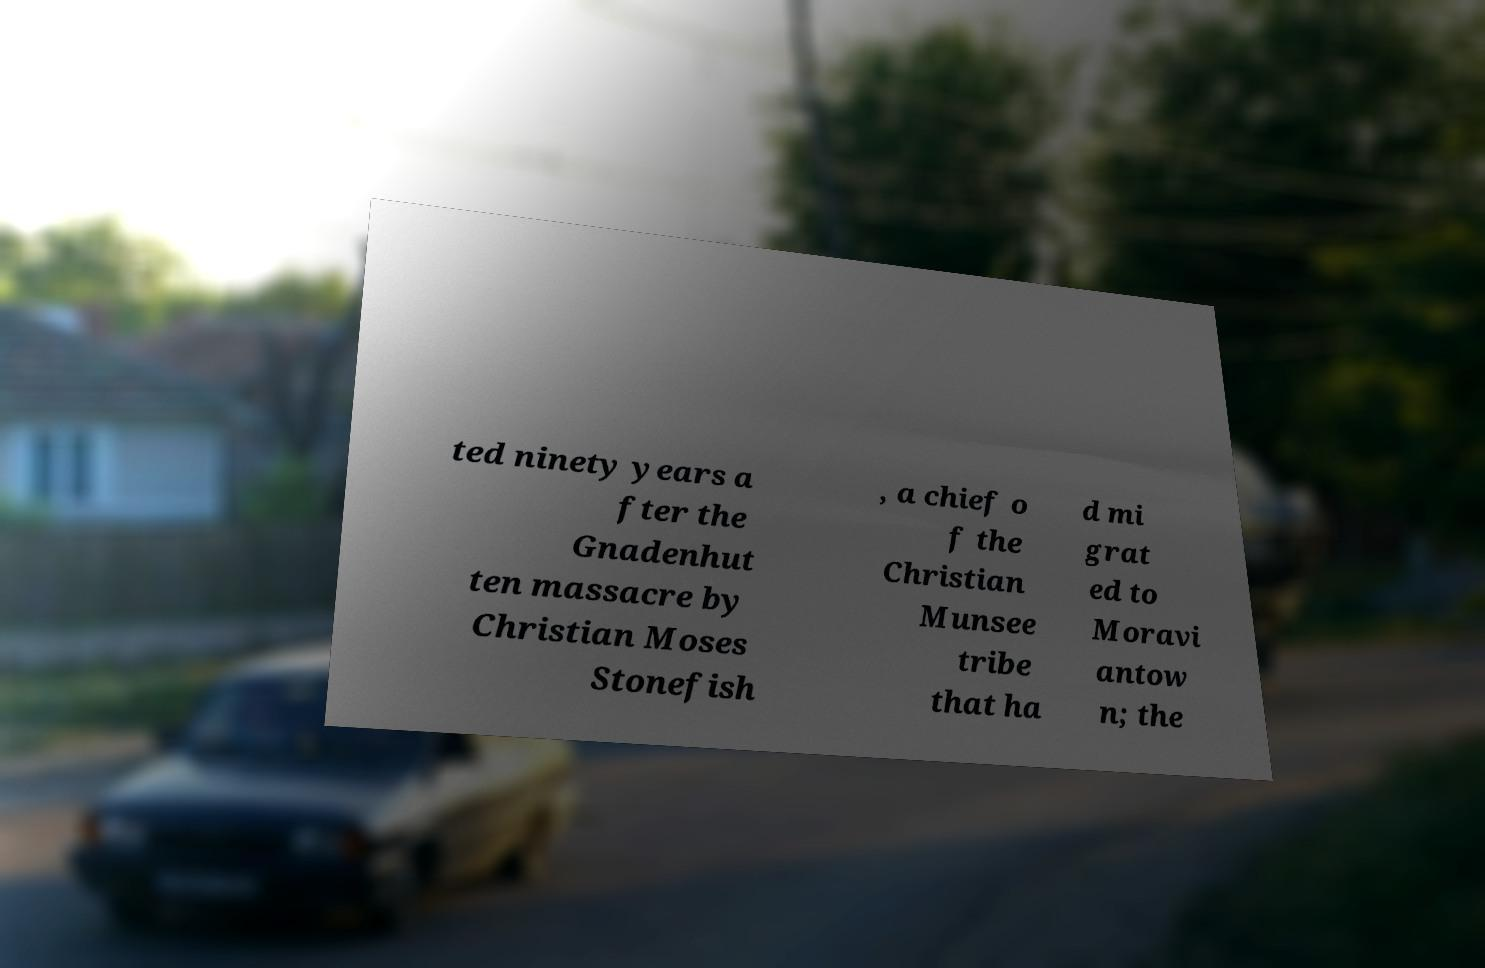For documentation purposes, I need the text within this image transcribed. Could you provide that? ted ninety years a fter the Gnadenhut ten massacre by Christian Moses Stonefish , a chief o f the Christian Munsee tribe that ha d mi grat ed to Moravi antow n; the 